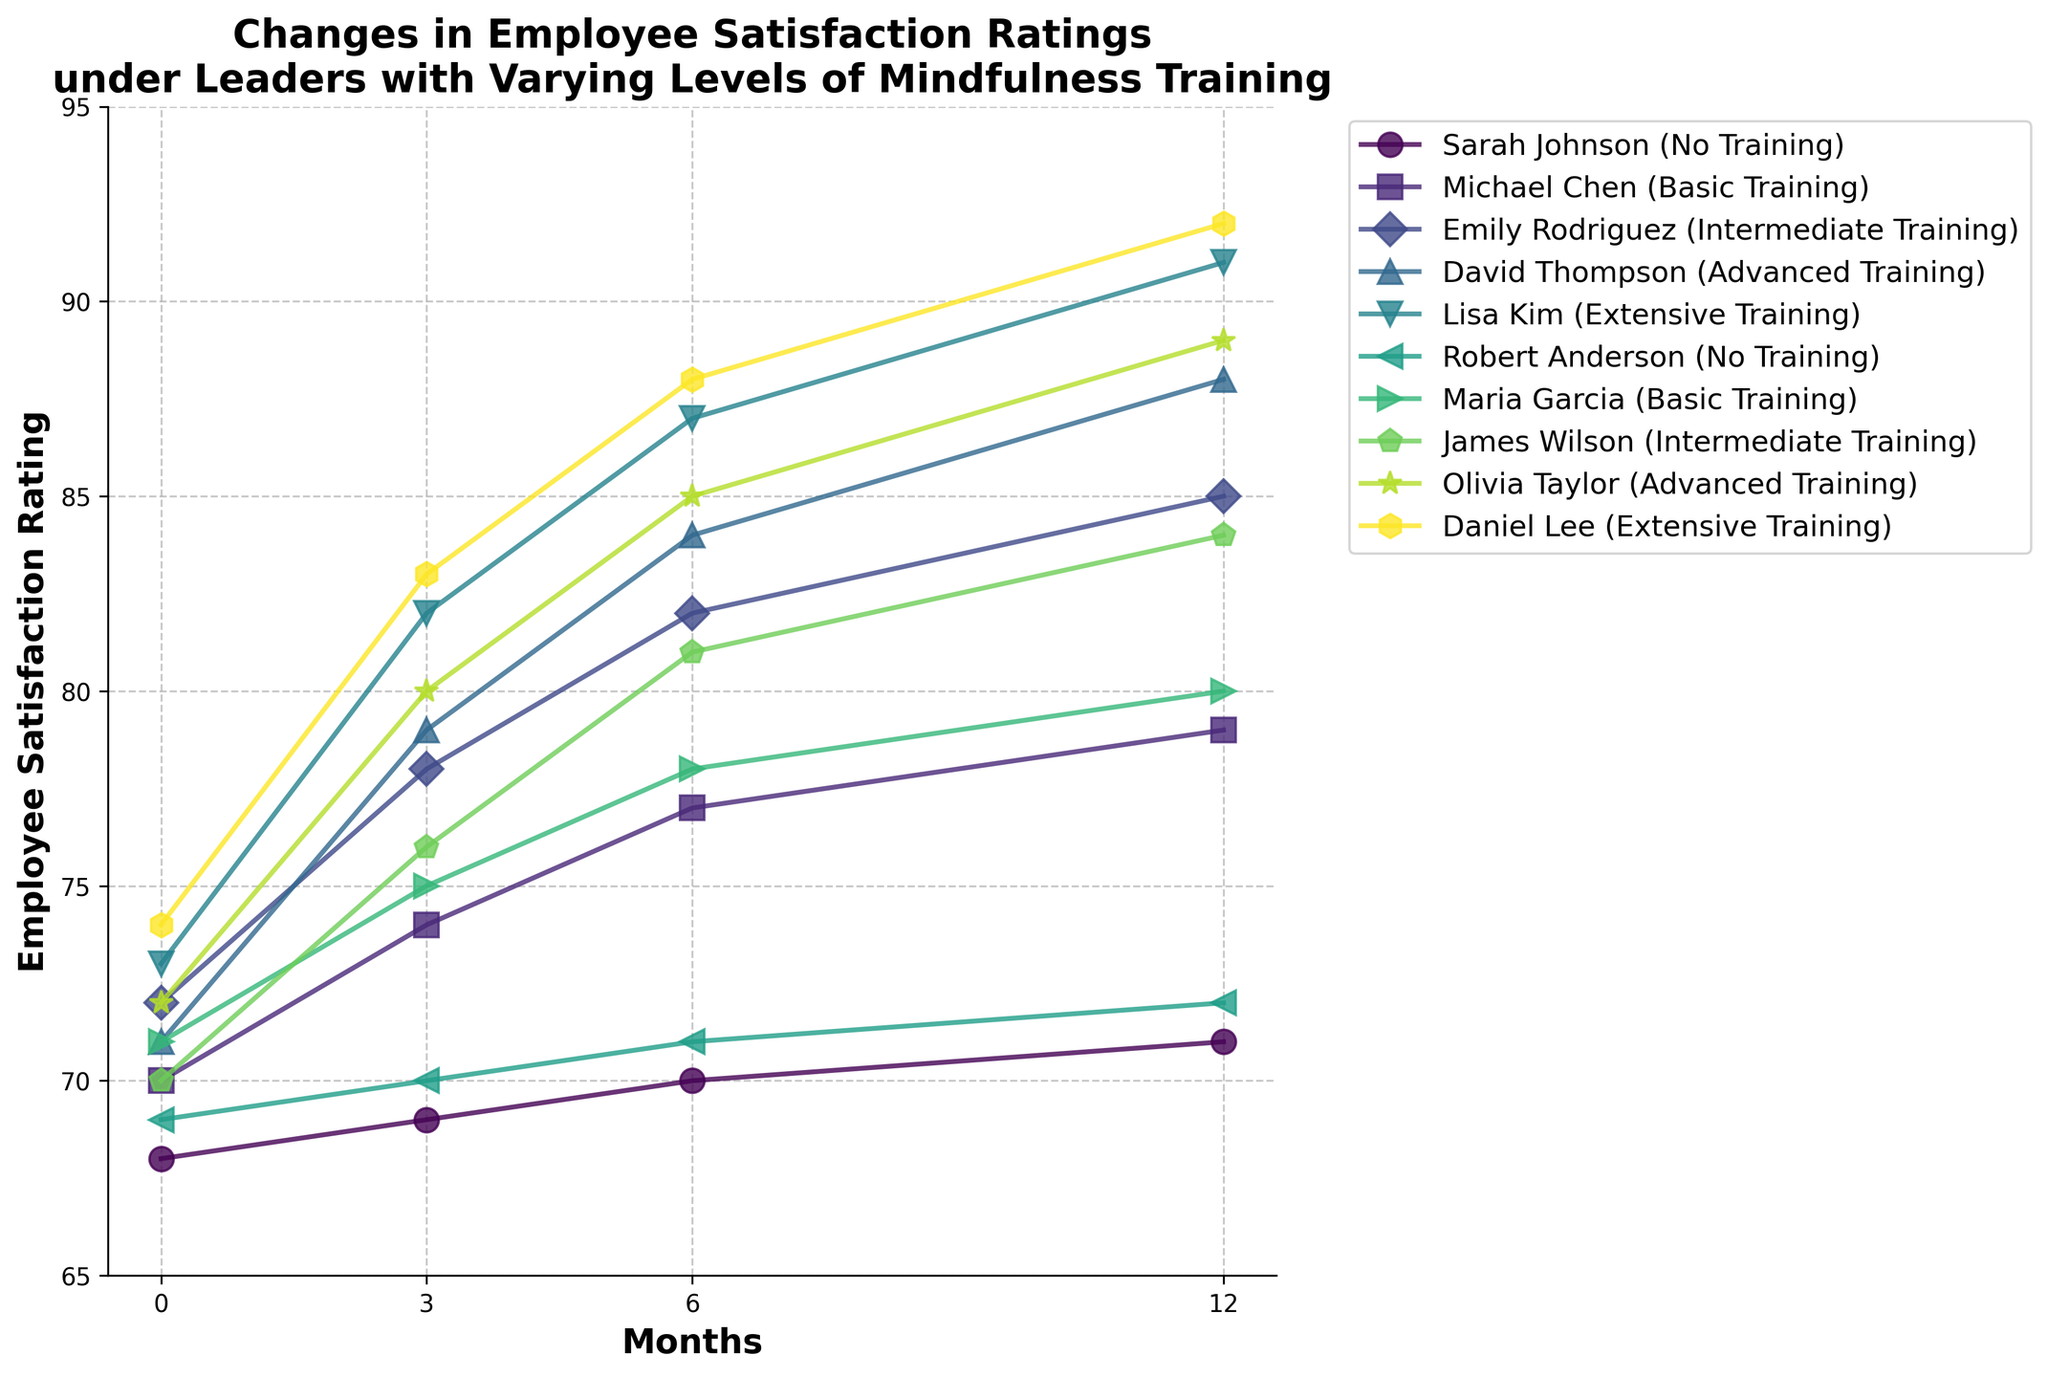What is the overall trend in employee satisfaction ratings for leaders with no training over the 12 months? The ratings for leaders with no training (Sarah Johnson and Robert Anderson) show a gradual and slight increase over the 12 months, from around 68-69 to 71-72. This indicates a consistent but modest improvement in employee satisfaction.
Answer: Slight increase Between the leaders with advanced training and those with extensive training, which group shows a higher increase in employee satisfaction from 0 to 12 months? Comparing David Thompson (advanced training) and Olivia Taylor (advanced training) with Lisa Kim (extensive training) and Daniel Lee (extensive training), the extensive training group shows a higher increase in satisfaction. David's increase is from 71 to 88 and Olivia's from 72 to 89, while Lisa's is from 73 to 91 and Daniel's from 74 to 92.
Answer: Extensive training Which leader shows the greatest total increase in employee satisfaction rating from 0 to 12 months? To find this, calculate the difference between the 12-month and 0-month ratings for each leader. David Thompson (88-71=17), Lisa Kim (91-73=18), and Daniel Lee (92-74=18) show the largest increases, with Daniel Lee having the highest satisfaction rating at month 0 and 12.
Answer: Daniel Lee, Lisa Kim How do the trends in employee satisfaction ratings compare between leaders who underwent basic training and those who underwent intermediate training? Leaders with basic training (Michael Chen and Maria Garcia) show a gradual increase from around 70-71 to 79-80. Leaders with intermediate training (Emily Rodriguez and James Wilson) display a more significant increase, from about 72-70 to 85-84.
Answer: Intermediate training had a higher increase What is the average employee satisfaction rating of all leaders at 6 months? Sum the ratings for all leaders at 6 months and divide by the number of leaders. (70+77+82+84+87+71+78+81+85+88) / 10 = 80.3
Answer: 80.3 Which leader has the lowest initial employee satisfaction rating, and do they show an improvement trend? Sarah Johnson starts with the lowest rating at 68. Her ratings show a consistent improvement trend, increasing to 69, 70, and 71 over 12 months.
Answer: Sarah Johnson, yes What can be inferred about the correlation between the level of mindfulness training and employee satisfaction over time? From the figure, leaders with higher levels of mindfulness training (extensive training) tend to show a larger increase in employee satisfaction over the 12 months compared to those with no or basic training. This indicates a positive correlation.
Answer: Positive correlation Compare the satisfaction ratings' growth rate over the first 6 months versus the last 6 months for Emily Rodriguez (intermediate training) and Lisa Kim (extensive training). For Emily Rodriguez: First 6 months growth (82-72=10), Last 6 months growth (85-82=3). For Lisa Kim: First 6 months growth (87-73=14), Last 6 months growth (91-87=4).
Answer: Lisa Kim had a higher growth rate in the first 6 months compared to Emily Rodriguez What is the difference in the employee satisfaction increase from initial to final measurement between Michael Chen (basic training) and Sarah Johnson (no training)? Calculate the differences for both: Michael Chen (79-70=9), Sarah Johnson (71-68=3). The difference in their increases is 9-3 = 6.
Answer: 6 